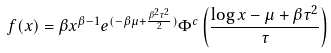<formula> <loc_0><loc_0><loc_500><loc_500>f ( x ) = \beta x ^ { \beta - 1 } e ^ { ( - \beta \mu + \frac { \beta ^ { 2 } \tau ^ { 2 } } { 2 } ) } \Phi ^ { c } \left ( \frac { \log { x } - \mu + \beta \tau ^ { 2 } } { \tau } \right )</formula> 